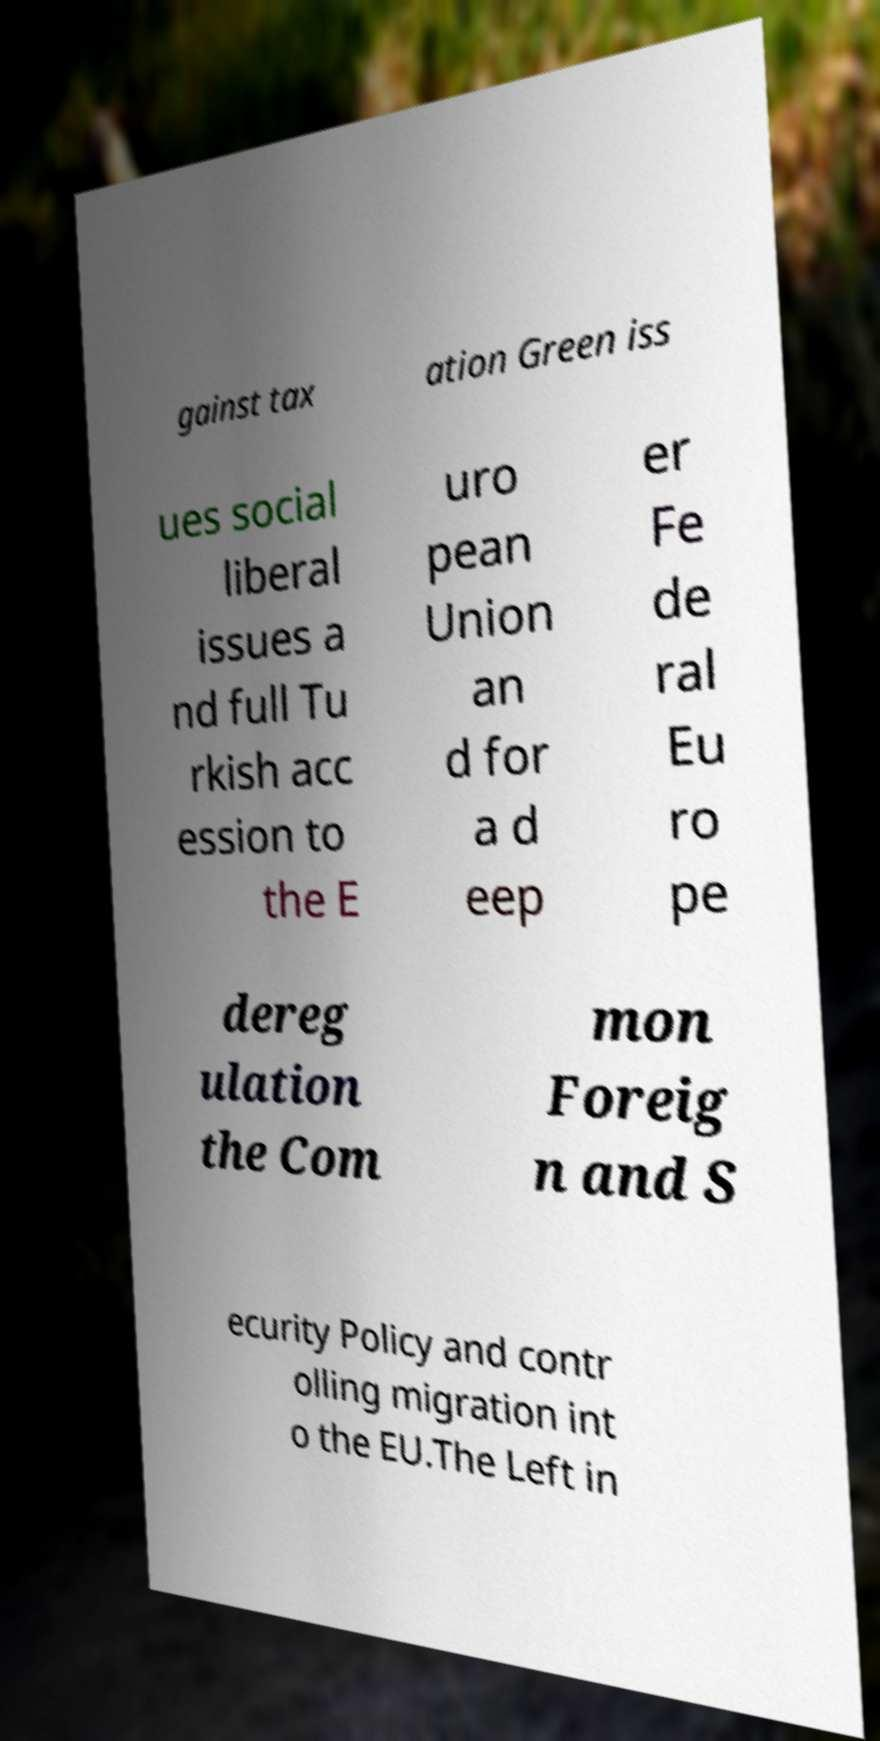Can you accurately transcribe the text from the provided image for me? gainst tax ation Green iss ues social liberal issues a nd full Tu rkish acc ession to the E uro pean Union an d for a d eep er Fe de ral Eu ro pe dereg ulation the Com mon Foreig n and S ecurity Policy and contr olling migration int o the EU.The Left in 